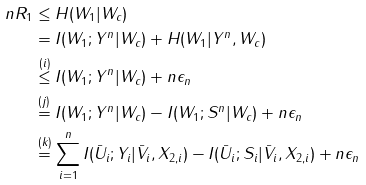<formula> <loc_0><loc_0><loc_500><loc_500>n R _ { 1 } & \leq H ( W _ { 1 } | W _ { c } ) \\ & = I ( W _ { 1 } ; Y ^ { n } | W _ { c } ) + H ( W _ { 1 } | Y ^ { n } , W _ { c } ) \\ & \stackrel { ( i ) } { \leq } I ( W _ { 1 } ; Y ^ { n } | W _ { c } ) + n \epsilon _ { n } \\ & \stackrel { ( j ) } { = } I ( W _ { 1 } ; Y ^ { n } | W _ { c } ) - I ( W _ { 1 } ; S ^ { n } | W _ { c } ) + n \epsilon _ { n } \\ & \stackrel { ( k ) } { = } \sum _ { i = 1 } ^ { n } I ( \bar { U } _ { i } ; Y _ { i } | \bar { V } _ { i } , X _ { 2 , i } ) - I ( \bar { U } _ { i } ; S _ { i } | \bar { V } _ { i } , X _ { 2 , i } ) + n \epsilon _ { n }</formula> 